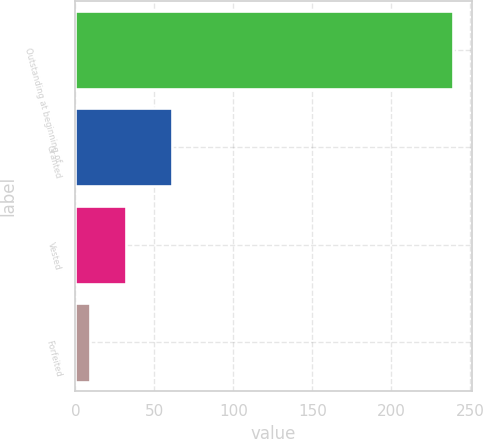Convert chart to OTSL. <chart><loc_0><loc_0><loc_500><loc_500><bar_chart><fcel>Outstanding at beginning of<fcel>Granted<fcel>Vested<fcel>Forfeited<nl><fcel>239<fcel>61<fcel>32<fcel>9<nl></chart> 